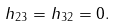Convert formula to latex. <formula><loc_0><loc_0><loc_500><loc_500>h _ { 2 3 } = h _ { 3 2 } = 0 .</formula> 